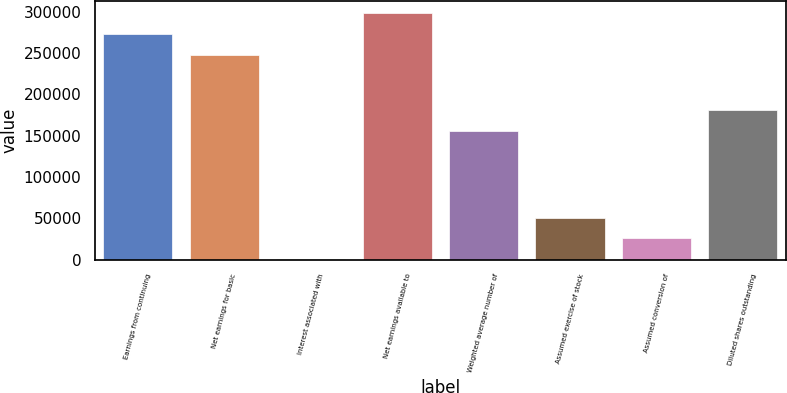<chart> <loc_0><loc_0><loc_500><loc_500><bar_chart><fcel>Earnings from continuing<fcel>Net earnings for basic<fcel>Interest associated with<fcel>Net earnings available to<fcel>Weighted average number of<fcel>Assumed exercise of stock<fcel>Assumed conversion of<fcel>Diluted shares outstanding<nl><fcel>272939<fcel>248126<fcel>935<fcel>297751<fcel>156141<fcel>50560.2<fcel>25747.6<fcel>180954<nl></chart> 